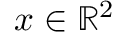<formula> <loc_0><loc_0><loc_500><loc_500>x \in \mathbb { R } ^ { 2 }</formula> 